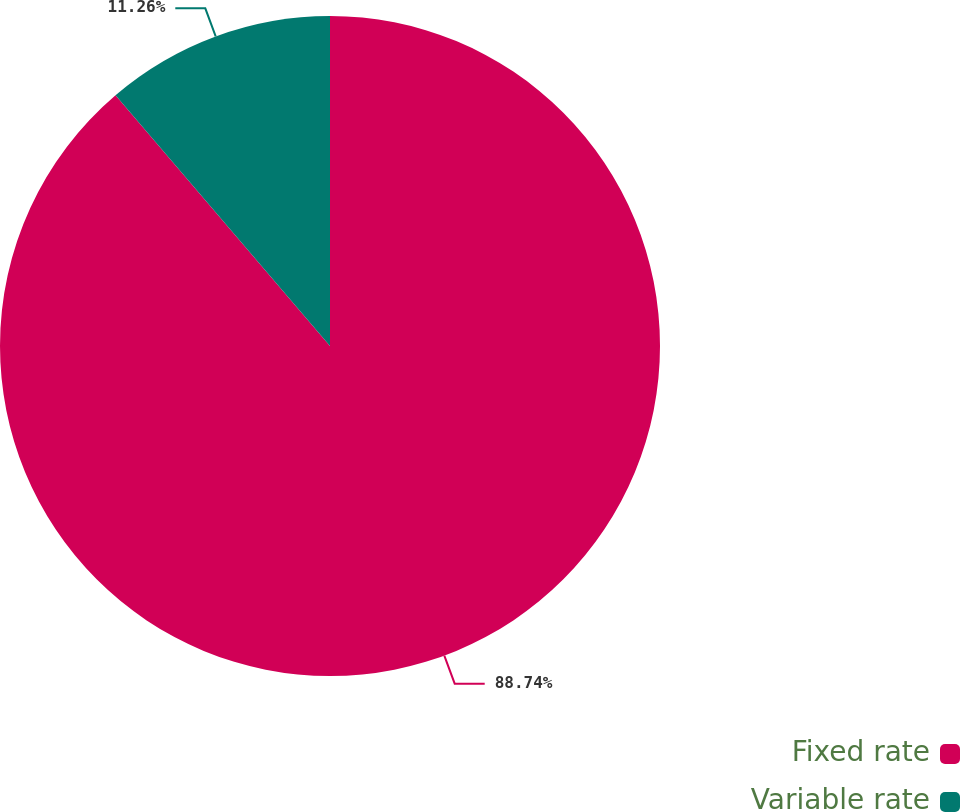Convert chart to OTSL. <chart><loc_0><loc_0><loc_500><loc_500><pie_chart><fcel>Fixed rate<fcel>Variable rate<nl><fcel>88.74%<fcel>11.26%<nl></chart> 